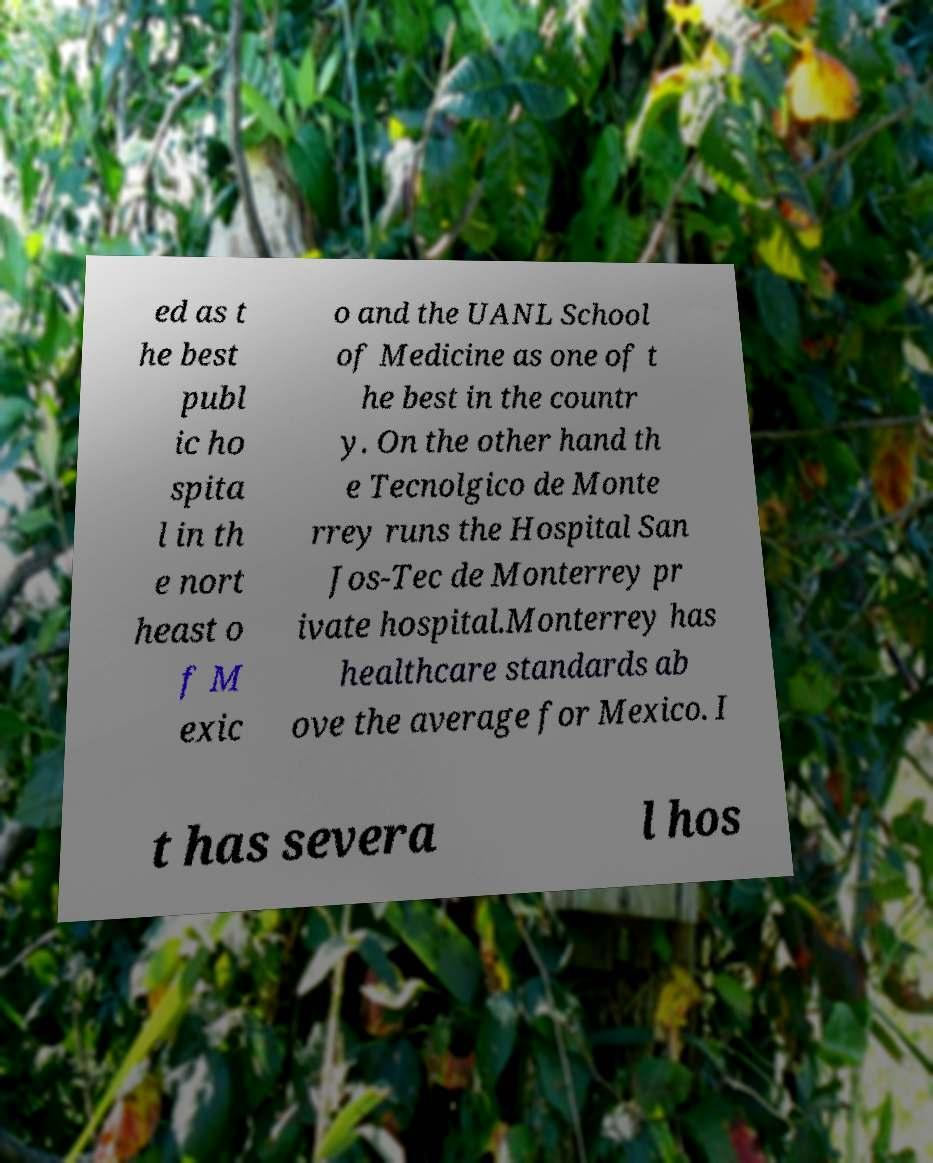Please identify and transcribe the text found in this image. ed as t he best publ ic ho spita l in th e nort heast o f M exic o and the UANL School of Medicine as one of t he best in the countr y. On the other hand th e Tecnolgico de Monte rrey runs the Hospital San Jos-Tec de Monterrey pr ivate hospital.Monterrey has healthcare standards ab ove the average for Mexico. I t has severa l hos 